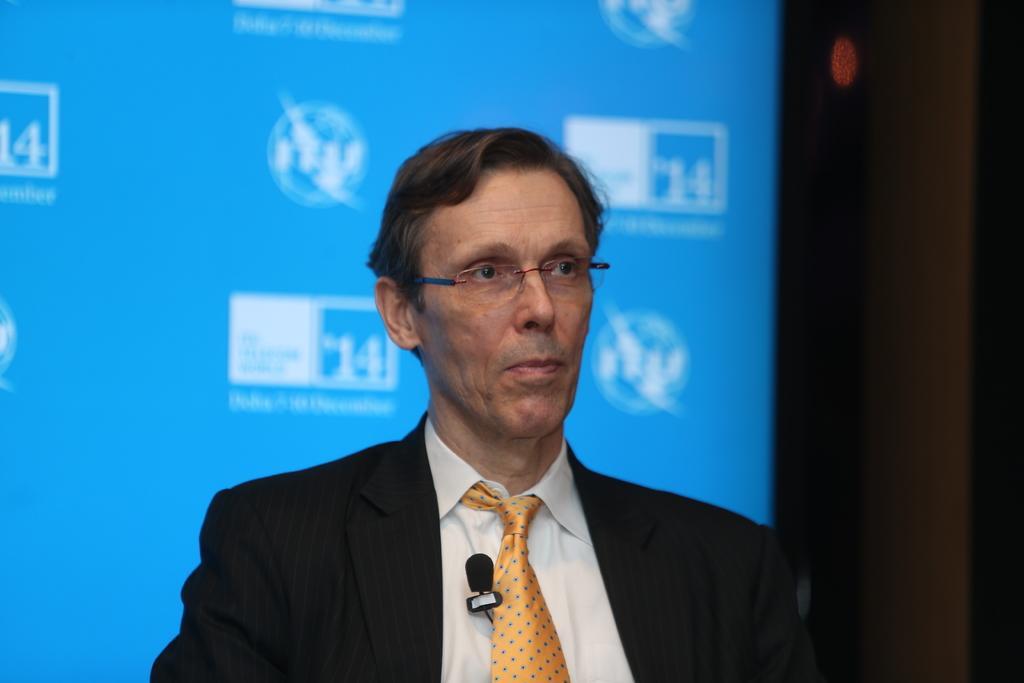Can you describe this image briefly? In this picture we can see a man, he wore a suit and spectacles, in the background there is a screen. 